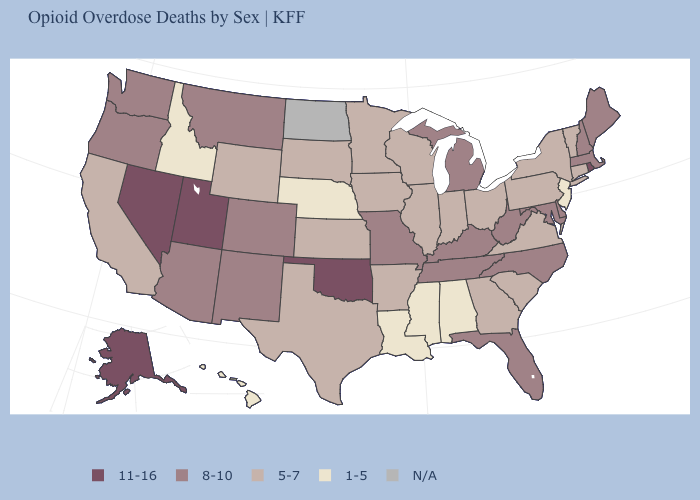What is the value of Connecticut?
Short answer required. 5-7. Among the states that border Pennsylvania , which have the highest value?
Short answer required. Delaware, Maryland, West Virginia. What is the value of North Carolina?
Concise answer only. 8-10. Among the states that border Wisconsin , does Illinois have the lowest value?
Give a very brief answer. Yes. Does Arkansas have the lowest value in the USA?
Give a very brief answer. No. Name the states that have a value in the range N/A?
Quick response, please. North Dakota. Among the states that border West Virginia , which have the highest value?
Be succinct. Kentucky, Maryland. What is the lowest value in the USA?
Write a very short answer. 1-5. What is the value of Arkansas?
Write a very short answer. 5-7. What is the highest value in states that border Idaho?
Be succinct. 11-16. Does Colorado have the highest value in the USA?
Quick response, please. No. How many symbols are there in the legend?
Quick response, please. 5. Which states hav the highest value in the MidWest?
Concise answer only. Michigan, Missouri. 